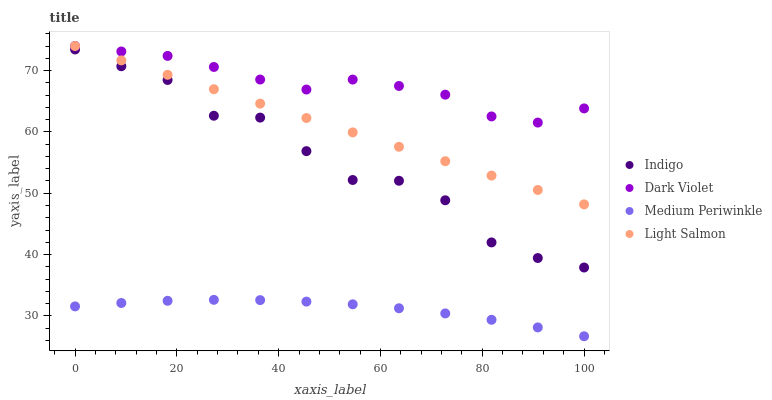Does Medium Periwinkle have the minimum area under the curve?
Answer yes or no. Yes. Does Dark Violet have the maximum area under the curve?
Answer yes or no. Yes. Does Light Salmon have the minimum area under the curve?
Answer yes or no. No. Does Light Salmon have the maximum area under the curve?
Answer yes or no. No. Is Light Salmon the smoothest?
Answer yes or no. Yes. Is Indigo the roughest?
Answer yes or no. Yes. Is Indigo the smoothest?
Answer yes or no. No. Is Light Salmon the roughest?
Answer yes or no. No. Does Medium Periwinkle have the lowest value?
Answer yes or no. Yes. Does Light Salmon have the lowest value?
Answer yes or no. No. Does Dark Violet have the highest value?
Answer yes or no. Yes. Does Indigo have the highest value?
Answer yes or no. No. Is Medium Periwinkle less than Dark Violet?
Answer yes or no. Yes. Is Indigo greater than Medium Periwinkle?
Answer yes or no. Yes. Does Dark Violet intersect Light Salmon?
Answer yes or no. Yes. Is Dark Violet less than Light Salmon?
Answer yes or no. No. Is Dark Violet greater than Light Salmon?
Answer yes or no. No. Does Medium Periwinkle intersect Dark Violet?
Answer yes or no. No. 